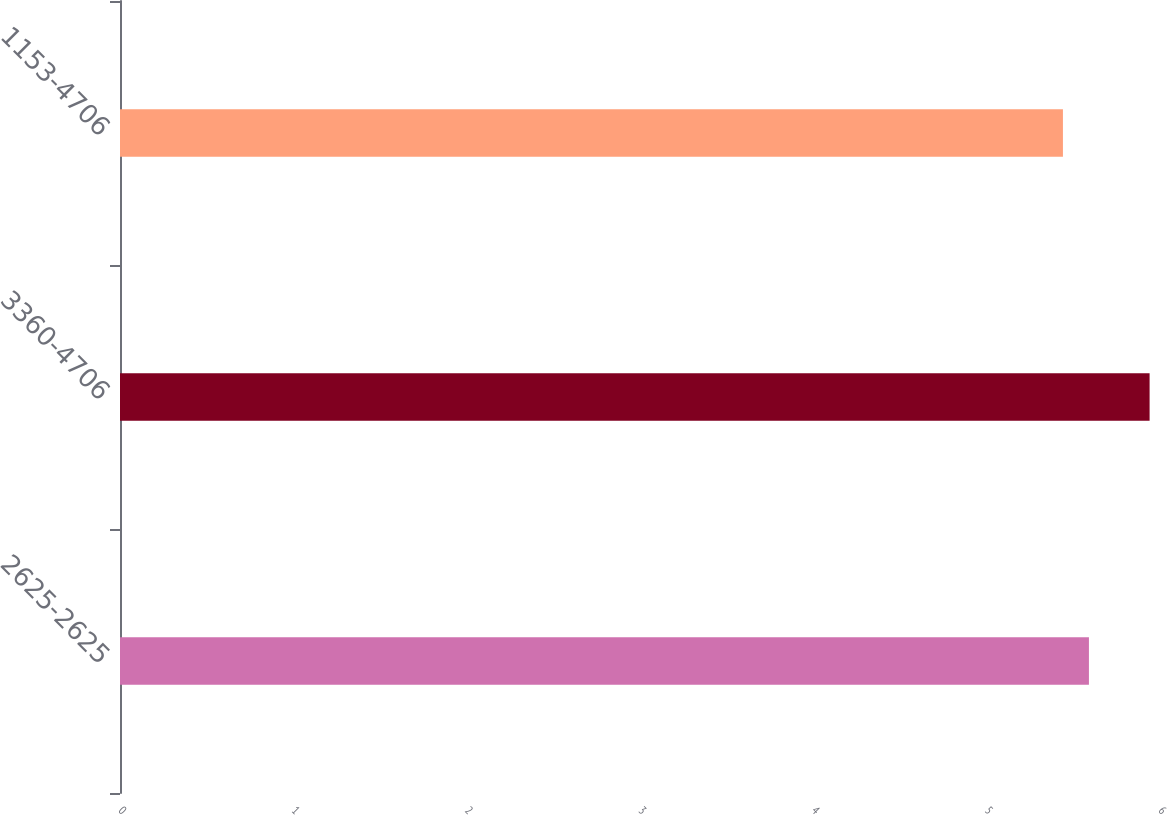Convert chart to OTSL. <chart><loc_0><loc_0><loc_500><loc_500><bar_chart><fcel>2625-2625<fcel>3360-4706<fcel>1153-4706<nl><fcel>5.59<fcel>5.94<fcel>5.44<nl></chart> 